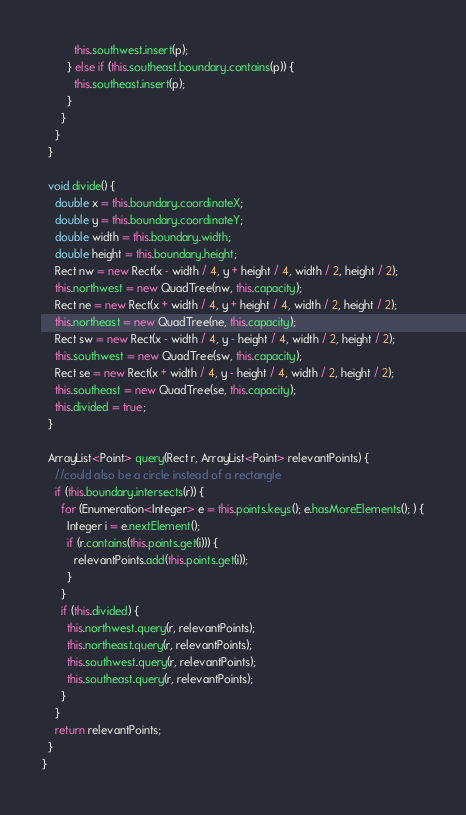Convert code to text. <code><loc_0><loc_0><loc_500><loc_500><_Java_>          this.southwest.insert(p);
        } else if (this.southeast.boundary.contains(p)) {
          this.southeast.insert(p);
        }
      }
    }
  }

  void divide() {
    double x = this.boundary.coordinateX;
    double y = this.boundary.coordinateY;
    double width = this.boundary.width;
    double height = this.boundary.height;
    Rect nw = new Rect(x - width / 4, y + height / 4, width / 2, height / 2);
    this.northwest = new QuadTree(nw, this.capacity);
    Rect ne = new Rect(x + width / 4, y + height / 4, width / 2, height / 2);
    this.northeast = new QuadTree(ne, this.capacity);
    Rect sw = new Rect(x - width / 4, y - height / 4, width / 2, height / 2);
    this.southwest = new QuadTree(sw, this.capacity);
    Rect se = new Rect(x + width / 4, y - height / 4, width / 2, height / 2);
    this.southeast = new QuadTree(se, this.capacity);
    this.divided = true;
  }

  ArrayList<Point> query(Rect r, ArrayList<Point> relevantPoints) {
    //could also be a circle instead of a rectangle
    if (this.boundary.intersects(r)) {
      for (Enumeration<Integer> e = this.points.keys(); e.hasMoreElements(); ) {
        Integer i = e.nextElement();
        if (r.contains(this.points.get(i))) {
          relevantPoints.add(this.points.get(i));
        }
      }
      if (this.divided) {
        this.northwest.query(r, relevantPoints);
        this.northeast.query(r, relevantPoints);
        this.southwest.query(r, relevantPoints);
        this.southeast.query(r, relevantPoints);
      }
    }
    return relevantPoints;
  }
}
</code> 